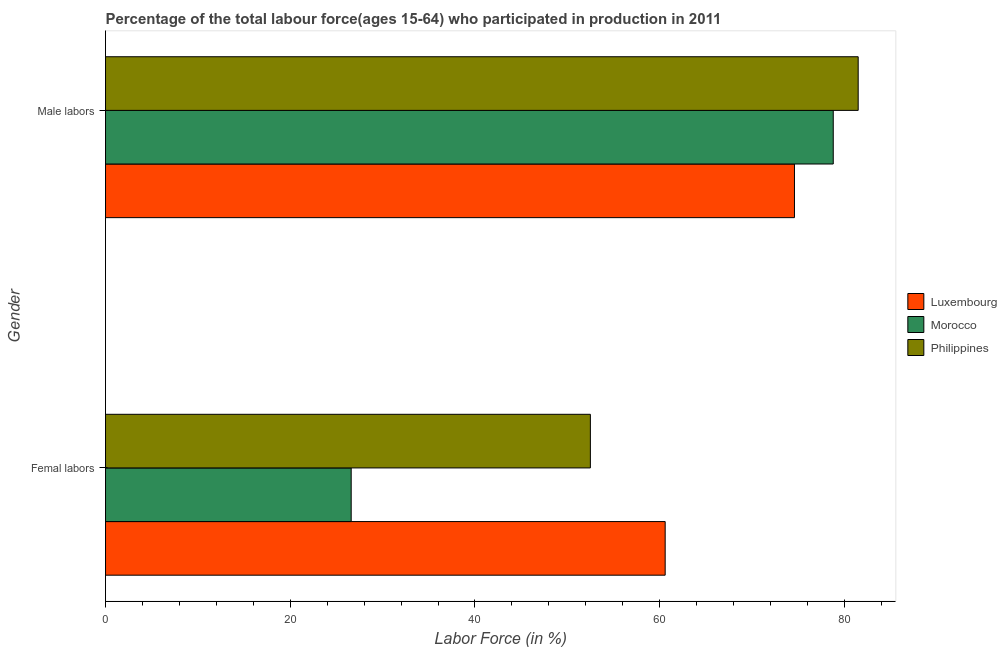How many groups of bars are there?
Offer a terse response. 2. How many bars are there on the 2nd tick from the top?
Offer a terse response. 3. What is the label of the 1st group of bars from the top?
Provide a succinct answer. Male labors. What is the percentage of male labour force in Luxembourg?
Your answer should be compact. 74.6. Across all countries, what is the maximum percentage of male labour force?
Your answer should be very brief. 81.5. Across all countries, what is the minimum percentage of female labor force?
Offer a very short reply. 26.6. In which country was the percentage of male labour force minimum?
Your answer should be very brief. Luxembourg. What is the total percentage of male labour force in the graph?
Make the answer very short. 234.9. What is the difference between the percentage of male labour force in Luxembourg and that in Morocco?
Offer a terse response. -4.2. What is the difference between the percentage of female labor force in Luxembourg and the percentage of male labour force in Morocco?
Ensure brevity in your answer.  -18.2. What is the average percentage of male labour force per country?
Give a very brief answer. 78.3. What is the difference between the percentage of male labour force and percentage of female labor force in Luxembourg?
Ensure brevity in your answer.  14. In how many countries, is the percentage of male labour force greater than 48 %?
Ensure brevity in your answer.  3. What is the ratio of the percentage of female labor force in Morocco to that in Philippines?
Make the answer very short. 0.51. In how many countries, is the percentage of male labour force greater than the average percentage of male labour force taken over all countries?
Make the answer very short. 2. What does the 3rd bar from the bottom in Femal labors represents?
Make the answer very short. Philippines. How many countries are there in the graph?
Provide a succinct answer. 3. What is the difference between two consecutive major ticks on the X-axis?
Offer a terse response. 20. Are the values on the major ticks of X-axis written in scientific E-notation?
Your response must be concise. No. Does the graph contain grids?
Offer a very short reply. No. Where does the legend appear in the graph?
Give a very brief answer. Center right. How are the legend labels stacked?
Your answer should be compact. Vertical. What is the title of the graph?
Provide a short and direct response. Percentage of the total labour force(ages 15-64) who participated in production in 2011. Does "Curacao" appear as one of the legend labels in the graph?
Ensure brevity in your answer.  No. What is the label or title of the X-axis?
Offer a very short reply. Labor Force (in %). What is the Labor Force (in %) of Luxembourg in Femal labors?
Offer a very short reply. 60.6. What is the Labor Force (in %) of Morocco in Femal labors?
Keep it short and to the point. 26.6. What is the Labor Force (in %) of Philippines in Femal labors?
Keep it short and to the point. 52.5. What is the Labor Force (in %) in Luxembourg in Male labors?
Your response must be concise. 74.6. What is the Labor Force (in %) in Morocco in Male labors?
Keep it short and to the point. 78.8. What is the Labor Force (in %) in Philippines in Male labors?
Your answer should be compact. 81.5. Across all Gender, what is the maximum Labor Force (in %) in Luxembourg?
Give a very brief answer. 74.6. Across all Gender, what is the maximum Labor Force (in %) in Morocco?
Offer a very short reply. 78.8. Across all Gender, what is the maximum Labor Force (in %) of Philippines?
Give a very brief answer. 81.5. Across all Gender, what is the minimum Labor Force (in %) in Luxembourg?
Provide a succinct answer. 60.6. Across all Gender, what is the minimum Labor Force (in %) in Morocco?
Your response must be concise. 26.6. Across all Gender, what is the minimum Labor Force (in %) in Philippines?
Make the answer very short. 52.5. What is the total Labor Force (in %) in Luxembourg in the graph?
Provide a short and direct response. 135.2. What is the total Labor Force (in %) of Morocco in the graph?
Provide a short and direct response. 105.4. What is the total Labor Force (in %) in Philippines in the graph?
Make the answer very short. 134. What is the difference between the Labor Force (in %) in Luxembourg in Femal labors and that in Male labors?
Ensure brevity in your answer.  -14. What is the difference between the Labor Force (in %) in Morocco in Femal labors and that in Male labors?
Provide a short and direct response. -52.2. What is the difference between the Labor Force (in %) in Luxembourg in Femal labors and the Labor Force (in %) in Morocco in Male labors?
Ensure brevity in your answer.  -18.2. What is the difference between the Labor Force (in %) of Luxembourg in Femal labors and the Labor Force (in %) of Philippines in Male labors?
Make the answer very short. -20.9. What is the difference between the Labor Force (in %) in Morocco in Femal labors and the Labor Force (in %) in Philippines in Male labors?
Provide a short and direct response. -54.9. What is the average Labor Force (in %) of Luxembourg per Gender?
Keep it short and to the point. 67.6. What is the average Labor Force (in %) of Morocco per Gender?
Keep it short and to the point. 52.7. What is the average Labor Force (in %) of Philippines per Gender?
Keep it short and to the point. 67. What is the difference between the Labor Force (in %) of Luxembourg and Labor Force (in %) of Morocco in Femal labors?
Your response must be concise. 34. What is the difference between the Labor Force (in %) of Luxembourg and Labor Force (in %) of Philippines in Femal labors?
Ensure brevity in your answer.  8.1. What is the difference between the Labor Force (in %) in Morocco and Labor Force (in %) in Philippines in Femal labors?
Provide a short and direct response. -25.9. What is the difference between the Labor Force (in %) of Luxembourg and Labor Force (in %) of Philippines in Male labors?
Your answer should be compact. -6.9. What is the difference between the Labor Force (in %) in Morocco and Labor Force (in %) in Philippines in Male labors?
Your response must be concise. -2.7. What is the ratio of the Labor Force (in %) in Luxembourg in Femal labors to that in Male labors?
Make the answer very short. 0.81. What is the ratio of the Labor Force (in %) of Morocco in Femal labors to that in Male labors?
Give a very brief answer. 0.34. What is the ratio of the Labor Force (in %) of Philippines in Femal labors to that in Male labors?
Provide a succinct answer. 0.64. What is the difference between the highest and the second highest Labor Force (in %) in Luxembourg?
Keep it short and to the point. 14. What is the difference between the highest and the second highest Labor Force (in %) in Morocco?
Offer a very short reply. 52.2. What is the difference between the highest and the second highest Labor Force (in %) of Philippines?
Your answer should be compact. 29. What is the difference between the highest and the lowest Labor Force (in %) of Morocco?
Provide a succinct answer. 52.2. What is the difference between the highest and the lowest Labor Force (in %) of Philippines?
Your answer should be very brief. 29. 